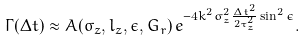Convert formula to latex. <formula><loc_0><loc_0><loc_500><loc_500>\Gamma ( \Delta t ) \approx A ( \sigma _ { z } , l _ { z } , \epsilon , G _ { r } ) \, e ^ { - 4 k ^ { 2 } \sigma _ { z } ^ { 2 } \frac { \Delta t ^ { 2 } } { 2 \tau _ { z } ^ { 2 } } \sin ^ { 2 } \epsilon } .</formula> 